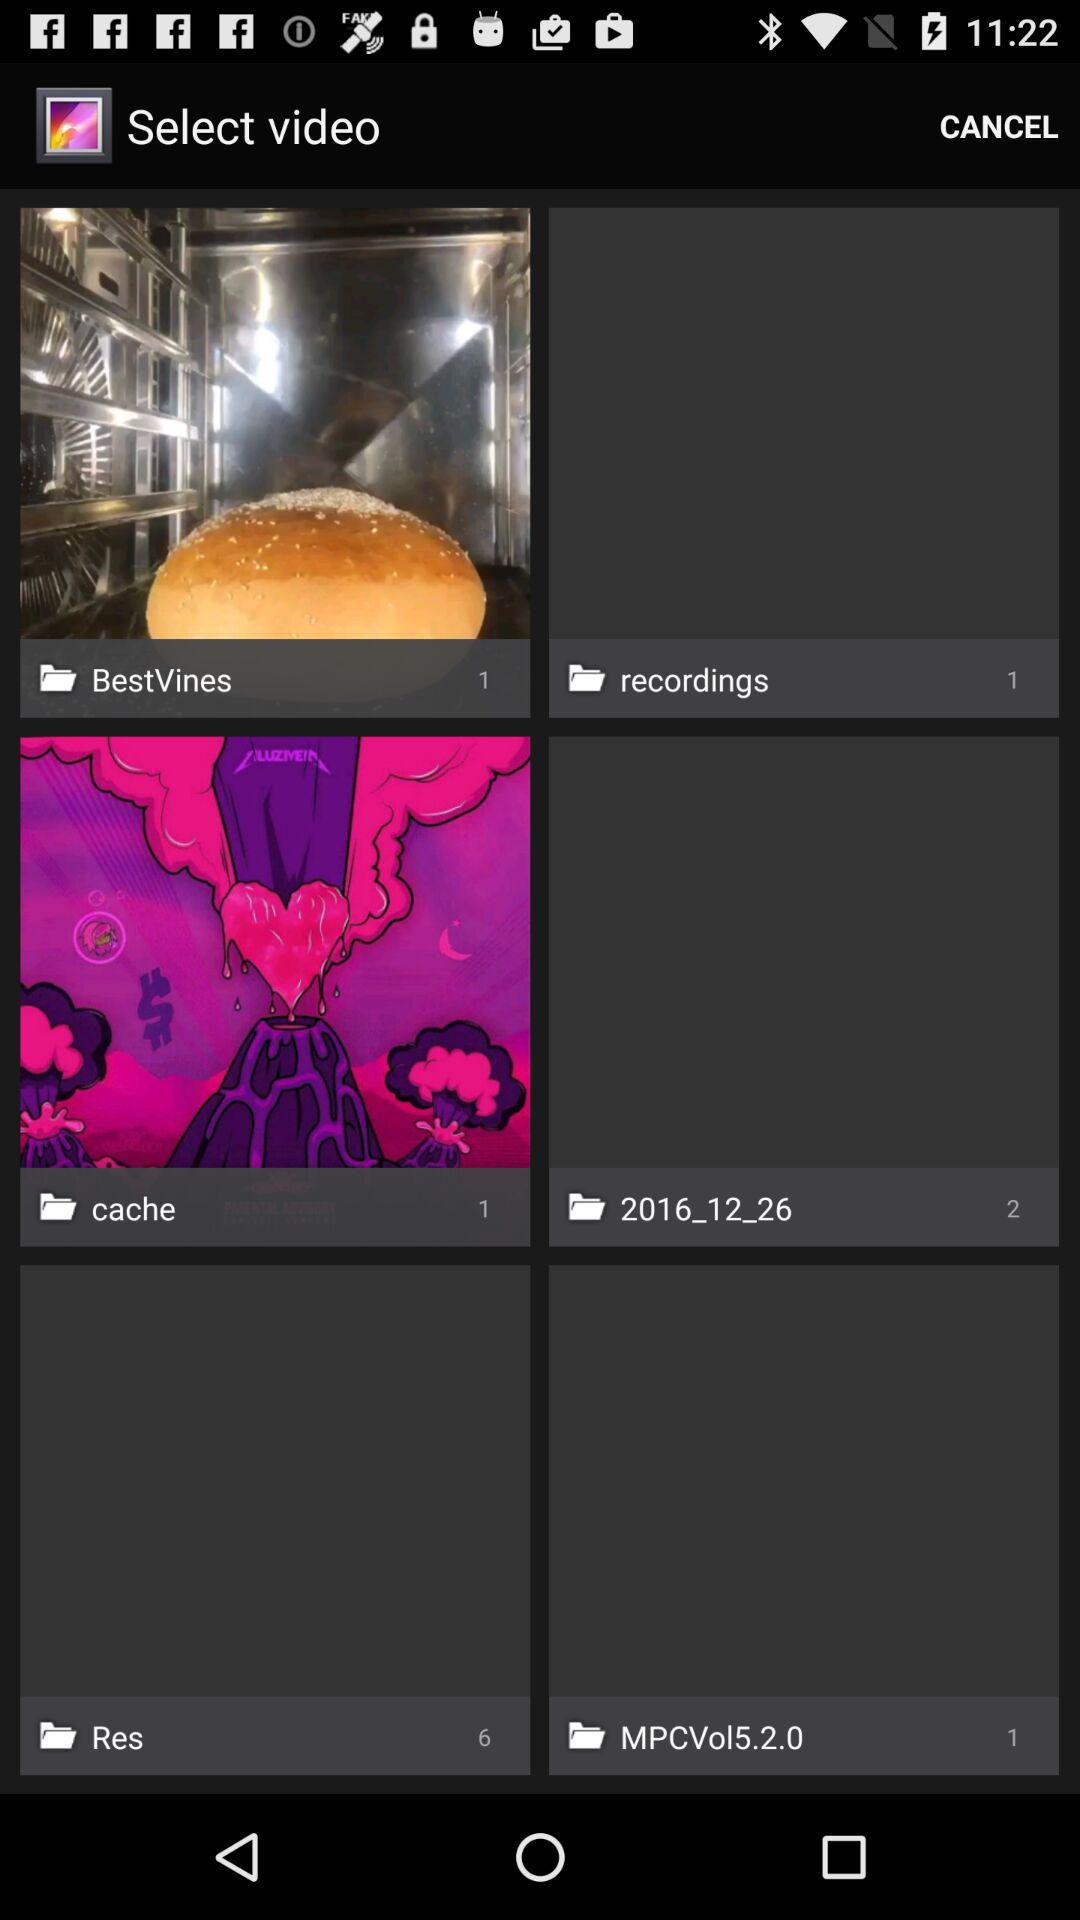What is the number of files in "recordings"? The number of files in "recordings" is 1. 